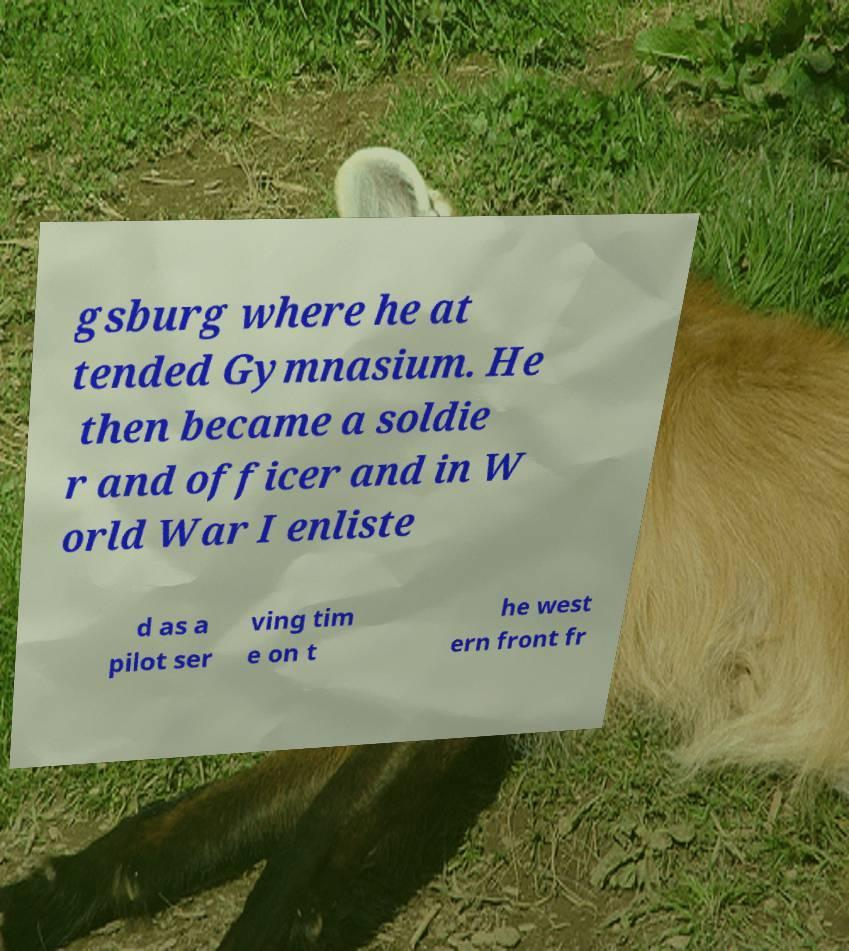Can you read and provide the text displayed in the image?This photo seems to have some interesting text. Can you extract and type it out for me? gsburg where he at tended Gymnasium. He then became a soldie r and officer and in W orld War I enliste d as a pilot ser ving tim e on t he west ern front fr 